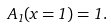Convert formula to latex. <formula><loc_0><loc_0><loc_500><loc_500>A _ { 1 } ( x = 1 ) = 1 .</formula> 